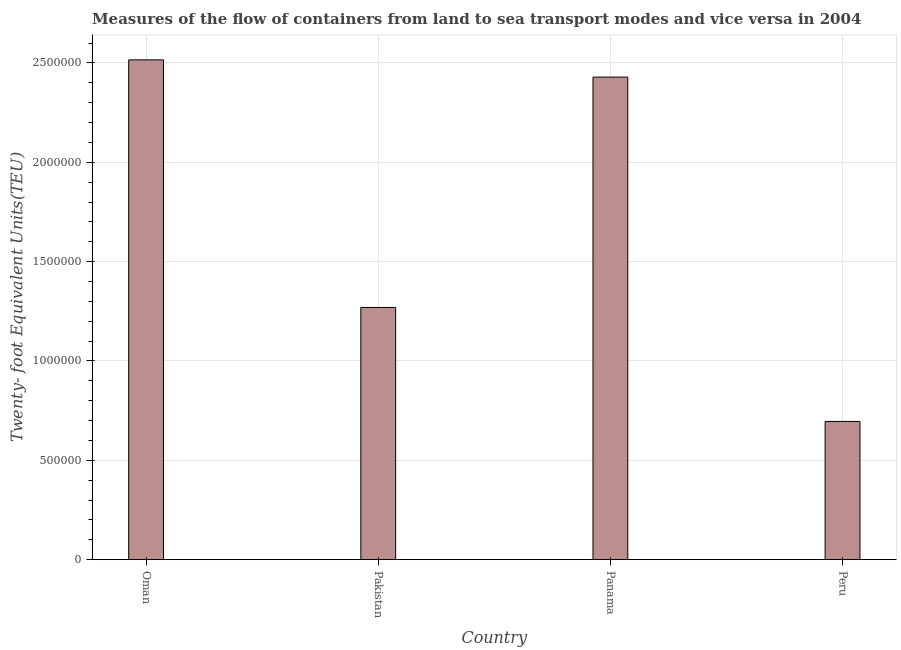Does the graph contain any zero values?
Your answer should be very brief. No. Does the graph contain grids?
Offer a very short reply. Yes. What is the title of the graph?
Your response must be concise. Measures of the flow of containers from land to sea transport modes and vice versa in 2004. What is the label or title of the Y-axis?
Provide a succinct answer. Twenty- foot Equivalent Units(TEU). What is the container port traffic in Pakistan?
Provide a succinct answer. 1.27e+06. Across all countries, what is the maximum container port traffic?
Ensure brevity in your answer.  2.52e+06. Across all countries, what is the minimum container port traffic?
Offer a terse response. 6.96e+05. In which country was the container port traffic maximum?
Ensure brevity in your answer.  Oman. In which country was the container port traffic minimum?
Offer a very short reply. Peru. What is the sum of the container port traffic?
Your answer should be compact. 6.91e+06. What is the difference between the container port traffic in Panama and Peru?
Ensure brevity in your answer.  1.73e+06. What is the average container port traffic per country?
Offer a terse response. 1.73e+06. What is the median container port traffic?
Keep it short and to the point. 1.85e+06. What is the ratio of the container port traffic in Oman to that in Pakistan?
Keep it short and to the point. 1.98. What is the difference between the highest and the second highest container port traffic?
Your answer should be very brief. 8.68e+04. What is the difference between the highest and the lowest container port traffic?
Give a very brief answer. 1.82e+06. In how many countries, is the container port traffic greater than the average container port traffic taken over all countries?
Provide a short and direct response. 2. How many bars are there?
Ensure brevity in your answer.  4. What is the difference between two consecutive major ticks on the Y-axis?
Provide a short and direct response. 5.00e+05. Are the values on the major ticks of Y-axis written in scientific E-notation?
Give a very brief answer. No. What is the Twenty- foot Equivalent Units(TEU) of Oman?
Offer a very short reply. 2.52e+06. What is the Twenty- foot Equivalent Units(TEU) in Pakistan?
Your answer should be very brief. 1.27e+06. What is the Twenty- foot Equivalent Units(TEU) of Panama?
Your answer should be very brief. 2.43e+06. What is the Twenty- foot Equivalent Units(TEU) in Peru?
Offer a terse response. 6.96e+05. What is the difference between the Twenty- foot Equivalent Units(TEU) in Oman and Pakistan?
Make the answer very short. 1.25e+06. What is the difference between the Twenty- foot Equivalent Units(TEU) in Oman and Panama?
Make the answer very short. 8.68e+04. What is the difference between the Twenty- foot Equivalent Units(TEU) in Oman and Peru?
Your answer should be compact. 1.82e+06. What is the difference between the Twenty- foot Equivalent Units(TEU) in Pakistan and Panama?
Offer a terse response. -1.16e+06. What is the difference between the Twenty- foot Equivalent Units(TEU) in Pakistan and Peru?
Offer a very short reply. 5.74e+05. What is the difference between the Twenty- foot Equivalent Units(TEU) in Panama and Peru?
Your response must be concise. 1.73e+06. What is the ratio of the Twenty- foot Equivalent Units(TEU) in Oman to that in Pakistan?
Make the answer very short. 1.98. What is the ratio of the Twenty- foot Equivalent Units(TEU) in Oman to that in Panama?
Offer a very short reply. 1.04. What is the ratio of the Twenty- foot Equivalent Units(TEU) in Oman to that in Peru?
Keep it short and to the point. 3.62. What is the ratio of the Twenty- foot Equivalent Units(TEU) in Pakistan to that in Panama?
Give a very brief answer. 0.52. What is the ratio of the Twenty- foot Equivalent Units(TEU) in Pakistan to that in Peru?
Make the answer very short. 1.82. What is the ratio of the Twenty- foot Equivalent Units(TEU) in Panama to that in Peru?
Your answer should be compact. 3.49. 